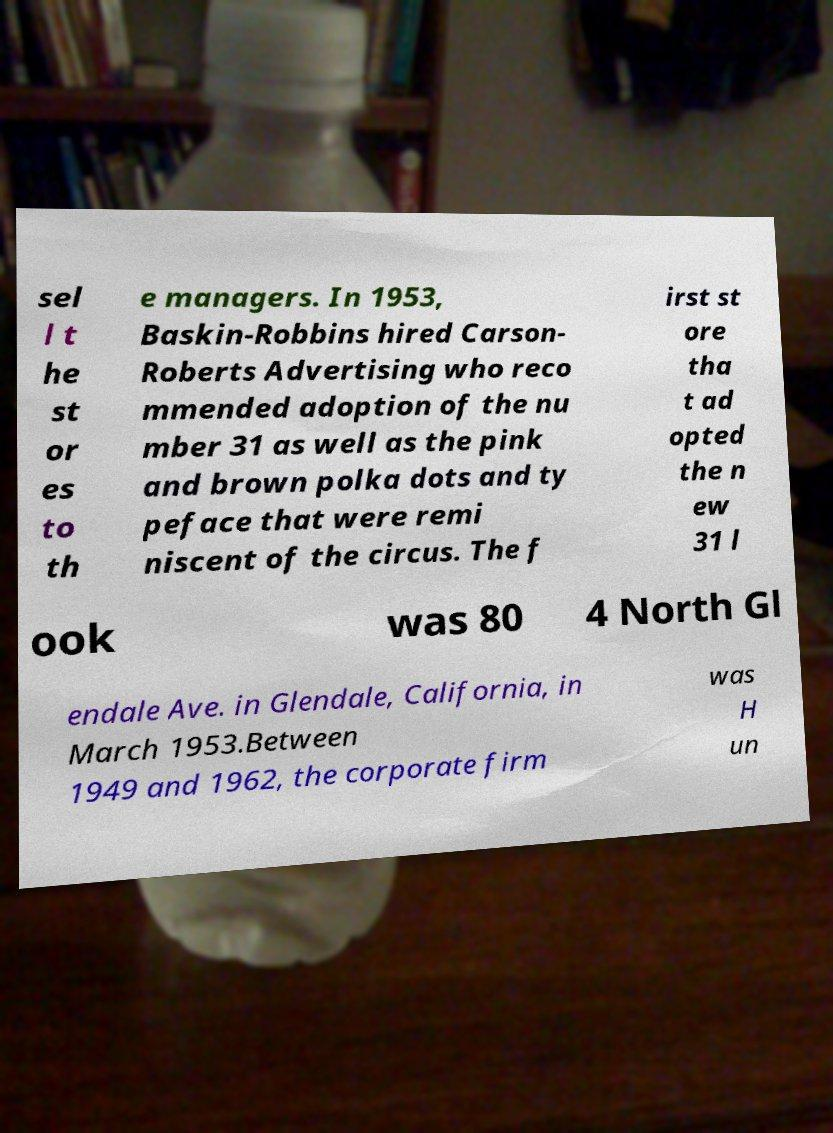I need the written content from this picture converted into text. Can you do that? sel l t he st or es to th e managers. In 1953, Baskin-Robbins hired Carson- Roberts Advertising who reco mmended adoption of the nu mber 31 as well as the pink and brown polka dots and ty peface that were remi niscent of the circus. The f irst st ore tha t ad opted the n ew 31 l ook was 80 4 North Gl endale Ave. in Glendale, California, in March 1953.Between 1949 and 1962, the corporate firm was H un 